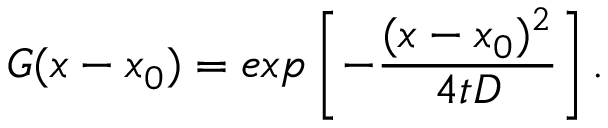Convert formula to latex. <formula><loc_0><loc_0><loc_500><loc_500>G ( x - x _ { 0 } ) = e x p \left [ - \frac { ( x - x _ { 0 } ) ^ { 2 } } { 4 t D } \right ] .</formula> 